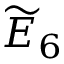<formula> <loc_0><loc_0><loc_500><loc_500>{ \widetilde { E } } _ { 6 }</formula> 